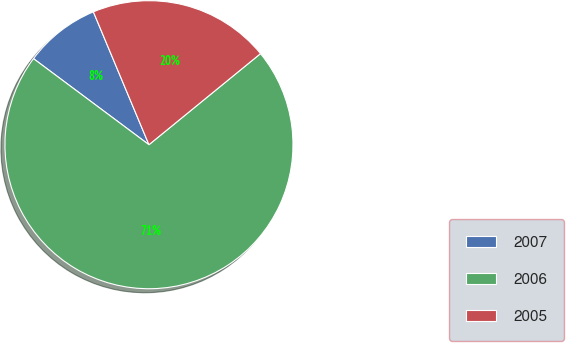Convert chart. <chart><loc_0><loc_0><loc_500><loc_500><pie_chart><fcel>2007<fcel>2006<fcel>2005<nl><fcel>8.5%<fcel>71.09%<fcel>20.41%<nl></chart> 